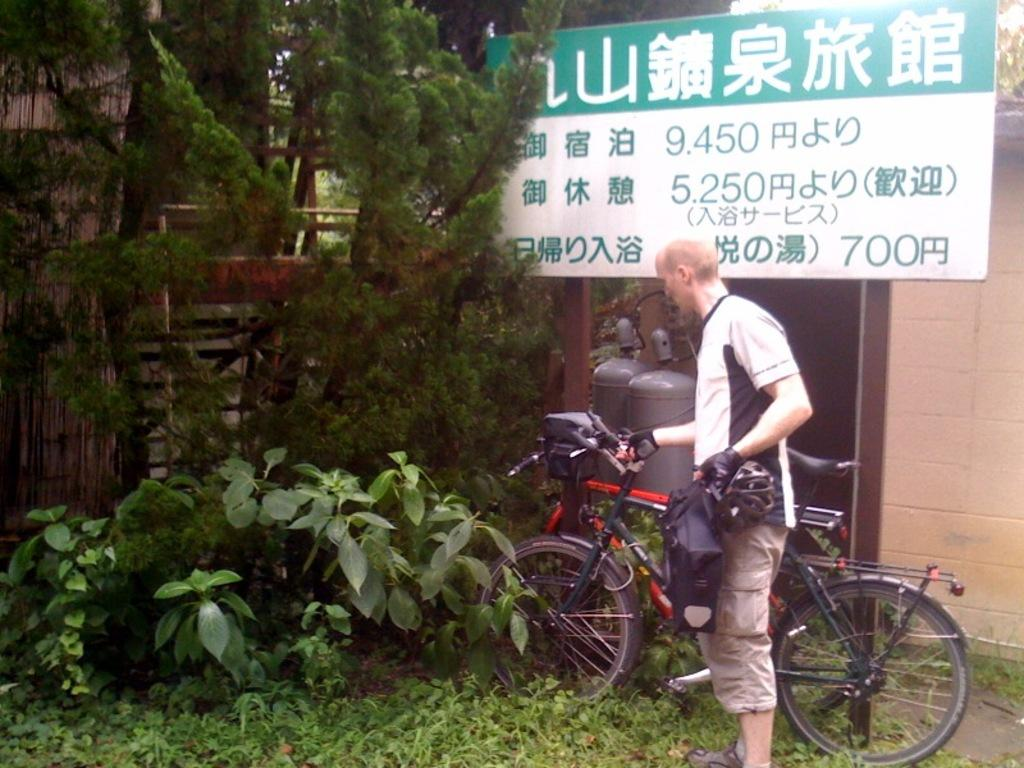What type of display is shown in the image? The image is a hoarding. Can you describe the person in the image? There is a man in the image, and he is wearing gloves. What is the man doing in the image? The man is standing near a bicycle. What type of natural elements can be seen in the image? There are plants and trees in the image. What type of loss is the man experiencing in the image? There is no indication of any loss in the image; the man is simply standing near a bicycle. What advice might the man's dad give him in the image? There is no dad present in the image, so it is not possible to determine what advice he might give. 